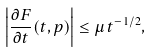<formula> <loc_0><loc_0><loc_500><loc_500>\left | \frac { \partial F } { \partial t } ( t , p ) \right | \leq \mu \, t ^ { - 1 / 2 } ,</formula> 